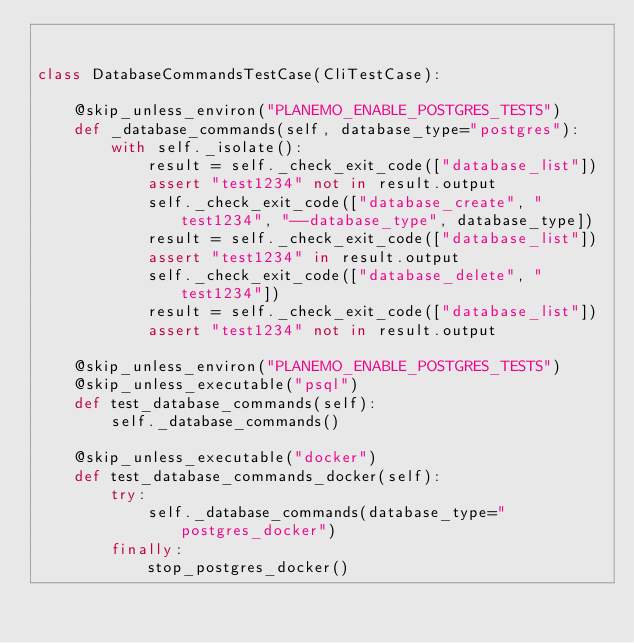Convert code to text. <code><loc_0><loc_0><loc_500><loc_500><_Python_>

class DatabaseCommandsTestCase(CliTestCase):

    @skip_unless_environ("PLANEMO_ENABLE_POSTGRES_TESTS")
    def _database_commands(self, database_type="postgres"):
        with self._isolate():
            result = self._check_exit_code(["database_list"])
            assert "test1234" not in result.output
            self._check_exit_code(["database_create", "test1234", "--database_type", database_type])
            result = self._check_exit_code(["database_list"])
            assert "test1234" in result.output
            self._check_exit_code(["database_delete", "test1234"])
            result = self._check_exit_code(["database_list"])
            assert "test1234" not in result.output

    @skip_unless_environ("PLANEMO_ENABLE_POSTGRES_TESTS")
    @skip_unless_executable("psql")
    def test_database_commands(self):
        self._database_commands()

    @skip_unless_executable("docker")
    def test_database_commands_docker(self):
        try:
            self._database_commands(database_type="postgres_docker")
        finally:
            stop_postgres_docker()
</code> 